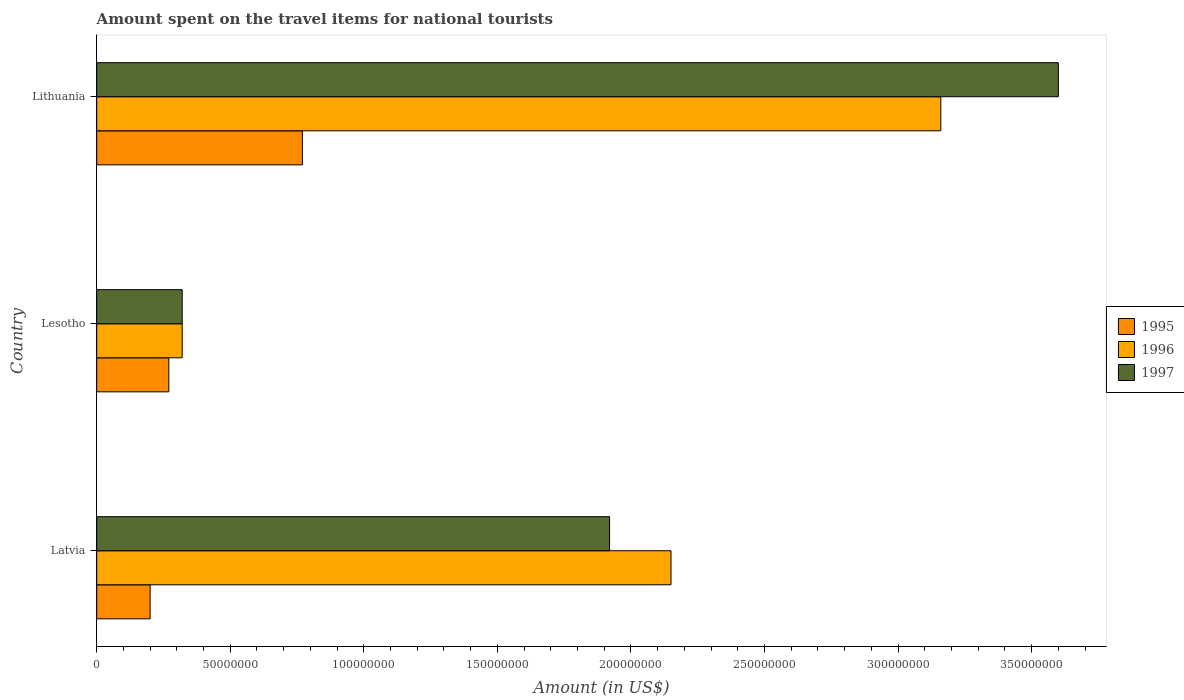How many groups of bars are there?
Ensure brevity in your answer.  3. Are the number of bars per tick equal to the number of legend labels?
Ensure brevity in your answer.  Yes. Are the number of bars on each tick of the Y-axis equal?
Ensure brevity in your answer.  Yes. How many bars are there on the 1st tick from the bottom?
Your response must be concise. 3. What is the label of the 2nd group of bars from the top?
Offer a very short reply. Lesotho. What is the amount spent on the travel items for national tourists in 1996 in Lesotho?
Provide a succinct answer. 3.20e+07. Across all countries, what is the maximum amount spent on the travel items for national tourists in 1997?
Provide a short and direct response. 3.60e+08. Across all countries, what is the minimum amount spent on the travel items for national tourists in 1996?
Provide a short and direct response. 3.20e+07. In which country was the amount spent on the travel items for national tourists in 1996 maximum?
Your answer should be very brief. Lithuania. In which country was the amount spent on the travel items for national tourists in 1997 minimum?
Your answer should be very brief. Lesotho. What is the total amount spent on the travel items for national tourists in 1996 in the graph?
Give a very brief answer. 5.63e+08. What is the difference between the amount spent on the travel items for national tourists in 1995 in Lesotho and that in Lithuania?
Your answer should be very brief. -5.00e+07. What is the difference between the amount spent on the travel items for national tourists in 1997 in Lithuania and the amount spent on the travel items for national tourists in 1996 in Latvia?
Your response must be concise. 1.45e+08. What is the average amount spent on the travel items for national tourists in 1996 per country?
Offer a terse response. 1.88e+08. In how many countries, is the amount spent on the travel items for national tourists in 1995 greater than 340000000 US$?
Offer a terse response. 0. What is the ratio of the amount spent on the travel items for national tourists in 1995 in Lesotho to that in Lithuania?
Offer a very short reply. 0.35. Is the difference between the amount spent on the travel items for national tourists in 1997 in Latvia and Lithuania greater than the difference between the amount spent on the travel items for national tourists in 1996 in Latvia and Lithuania?
Provide a succinct answer. No. What is the difference between the highest and the second highest amount spent on the travel items for national tourists in 1996?
Ensure brevity in your answer.  1.01e+08. What is the difference between the highest and the lowest amount spent on the travel items for national tourists in 1995?
Offer a very short reply. 5.70e+07. In how many countries, is the amount spent on the travel items for national tourists in 1996 greater than the average amount spent on the travel items for national tourists in 1996 taken over all countries?
Ensure brevity in your answer.  2. What does the 1st bar from the bottom in Lithuania represents?
Your response must be concise. 1995. Are all the bars in the graph horizontal?
Ensure brevity in your answer.  Yes. What is the difference between two consecutive major ticks on the X-axis?
Make the answer very short. 5.00e+07. Are the values on the major ticks of X-axis written in scientific E-notation?
Keep it short and to the point. No. Does the graph contain any zero values?
Offer a terse response. No. Where does the legend appear in the graph?
Offer a terse response. Center right. How many legend labels are there?
Offer a very short reply. 3. What is the title of the graph?
Provide a succinct answer. Amount spent on the travel items for national tourists. Does "1969" appear as one of the legend labels in the graph?
Your response must be concise. No. What is the label or title of the Y-axis?
Keep it short and to the point. Country. What is the Amount (in US$) in 1995 in Latvia?
Your response must be concise. 2.00e+07. What is the Amount (in US$) of 1996 in Latvia?
Your response must be concise. 2.15e+08. What is the Amount (in US$) in 1997 in Latvia?
Keep it short and to the point. 1.92e+08. What is the Amount (in US$) of 1995 in Lesotho?
Your response must be concise. 2.70e+07. What is the Amount (in US$) in 1996 in Lesotho?
Your response must be concise. 3.20e+07. What is the Amount (in US$) of 1997 in Lesotho?
Keep it short and to the point. 3.20e+07. What is the Amount (in US$) in 1995 in Lithuania?
Provide a short and direct response. 7.70e+07. What is the Amount (in US$) in 1996 in Lithuania?
Your answer should be compact. 3.16e+08. What is the Amount (in US$) of 1997 in Lithuania?
Ensure brevity in your answer.  3.60e+08. Across all countries, what is the maximum Amount (in US$) in 1995?
Offer a very short reply. 7.70e+07. Across all countries, what is the maximum Amount (in US$) in 1996?
Offer a very short reply. 3.16e+08. Across all countries, what is the maximum Amount (in US$) of 1997?
Your answer should be very brief. 3.60e+08. Across all countries, what is the minimum Amount (in US$) of 1995?
Your response must be concise. 2.00e+07. Across all countries, what is the minimum Amount (in US$) of 1996?
Make the answer very short. 3.20e+07. Across all countries, what is the minimum Amount (in US$) of 1997?
Provide a short and direct response. 3.20e+07. What is the total Amount (in US$) in 1995 in the graph?
Give a very brief answer. 1.24e+08. What is the total Amount (in US$) in 1996 in the graph?
Your answer should be very brief. 5.63e+08. What is the total Amount (in US$) in 1997 in the graph?
Your response must be concise. 5.84e+08. What is the difference between the Amount (in US$) in 1995 in Latvia and that in Lesotho?
Offer a very short reply. -7.00e+06. What is the difference between the Amount (in US$) in 1996 in Latvia and that in Lesotho?
Keep it short and to the point. 1.83e+08. What is the difference between the Amount (in US$) of 1997 in Latvia and that in Lesotho?
Make the answer very short. 1.60e+08. What is the difference between the Amount (in US$) in 1995 in Latvia and that in Lithuania?
Ensure brevity in your answer.  -5.70e+07. What is the difference between the Amount (in US$) in 1996 in Latvia and that in Lithuania?
Keep it short and to the point. -1.01e+08. What is the difference between the Amount (in US$) of 1997 in Latvia and that in Lithuania?
Give a very brief answer. -1.68e+08. What is the difference between the Amount (in US$) of 1995 in Lesotho and that in Lithuania?
Your answer should be compact. -5.00e+07. What is the difference between the Amount (in US$) in 1996 in Lesotho and that in Lithuania?
Ensure brevity in your answer.  -2.84e+08. What is the difference between the Amount (in US$) in 1997 in Lesotho and that in Lithuania?
Your response must be concise. -3.28e+08. What is the difference between the Amount (in US$) in 1995 in Latvia and the Amount (in US$) in 1996 in Lesotho?
Keep it short and to the point. -1.20e+07. What is the difference between the Amount (in US$) in 1995 in Latvia and the Amount (in US$) in 1997 in Lesotho?
Make the answer very short. -1.20e+07. What is the difference between the Amount (in US$) in 1996 in Latvia and the Amount (in US$) in 1997 in Lesotho?
Make the answer very short. 1.83e+08. What is the difference between the Amount (in US$) of 1995 in Latvia and the Amount (in US$) of 1996 in Lithuania?
Provide a succinct answer. -2.96e+08. What is the difference between the Amount (in US$) of 1995 in Latvia and the Amount (in US$) of 1997 in Lithuania?
Offer a terse response. -3.40e+08. What is the difference between the Amount (in US$) of 1996 in Latvia and the Amount (in US$) of 1997 in Lithuania?
Offer a very short reply. -1.45e+08. What is the difference between the Amount (in US$) in 1995 in Lesotho and the Amount (in US$) in 1996 in Lithuania?
Make the answer very short. -2.89e+08. What is the difference between the Amount (in US$) of 1995 in Lesotho and the Amount (in US$) of 1997 in Lithuania?
Provide a succinct answer. -3.33e+08. What is the difference between the Amount (in US$) of 1996 in Lesotho and the Amount (in US$) of 1997 in Lithuania?
Offer a terse response. -3.28e+08. What is the average Amount (in US$) of 1995 per country?
Provide a short and direct response. 4.13e+07. What is the average Amount (in US$) of 1996 per country?
Keep it short and to the point. 1.88e+08. What is the average Amount (in US$) of 1997 per country?
Your answer should be compact. 1.95e+08. What is the difference between the Amount (in US$) in 1995 and Amount (in US$) in 1996 in Latvia?
Keep it short and to the point. -1.95e+08. What is the difference between the Amount (in US$) of 1995 and Amount (in US$) of 1997 in Latvia?
Offer a very short reply. -1.72e+08. What is the difference between the Amount (in US$) in 1996 and Amount (in US$) in 1997 in Latvia?
Your response must be concise. 2.30e+07. What is the difference between the Amount (in US$) in 1995 and Amount (in US$) in 1996 in Lesotho?
Your answer should be compact. -5.00e+06. What is the difference between the Amount (in US$) in 1995 and Amount (in US$) in 1997 in Lesotho?
Your answer should be very brief. -5.00e+06. What is the difference between the Amount (in US$) in 1996 and Amount (in US$) in 1997 in Lesotho?
Your response must be concise. 0. What is the difference between the Amount (in US$) in 1995 and Amount (in US$) in 1996 in Lithuania?
Offer a very short reply. -2.39e+08. What is the difference between the Amount (in US$) in 1995 and Amount (in US$) in 1997 in Lithuania?
Your answer should be very brief. -2.83e+08. What is the difference between the Amount (in US$) of 1996 and Amount (in US$) of 1997 in Lithuania?
Provide a short and direct response. -4.40e+07. What is the ratio of the Amount (in US$) in 1995 in Latvia to that in Lesotho?
Offer a very short reply. 0.74. What is the ratio of the Amount (in US$) in 1996 in Latvia to that in Lesotho?
Provide a short and direct response. 6.72. What is the ratio of the Amount (in US$) of 1997 in Latvia to that in Lesotho?
Offer a very short reply. 6. What is the ratio of the Amount (in US$) in 1995 in Latvia to that in Lithuania?
Your response must be concise. 0.26. What is the ratio of the Amount (in US$) in 1996 in Latvia to that in Lithuania?
Keep it short and to the point. 0.68. What is the ratio of the Amount (in US$) in 1997 in Latvia to that in Lithuania?
Ensure brevity in your answer.  0.53. What is the ratio of the Amount (in US$) of 1995 in Lesotho to that in Lithuania?
Your response must be concise. 0.35. What is the ratio of the Amount (in US$) in 1996 in Lesotho to that in Lithuania?
Offer a terse response. 0.1. What is the ratio of the Amount (in US$) in 1997 in Lesotho to that in Lithuania?
Give a very brief answer. 0.09. What is the difference between the highest and the second highest Amount (in US$) of 1995?
Provide a succinct answer. 5.00e+07. What is the difference between the highest and the second highest Amount (in US$) of 1996?
Keep it short and to the point. 1.01e+08. What is the difference between the highest and the second highest Amount (in US$) in 1997?
Provide a succinct answer. 1.68e+08. What is the difference between the highest and the lowest Amount (in US$) in 1995?
Keep it short and to the point. 5.70e+07. What is the difference between the highest and the lowest Amount (in US$) in 1996?
Provide a short and direct response. 2.84e+08. What is the difference between the highest and the lowest Amount (in US$) in 1997?
Offer a terse response. 3.28e+08. 